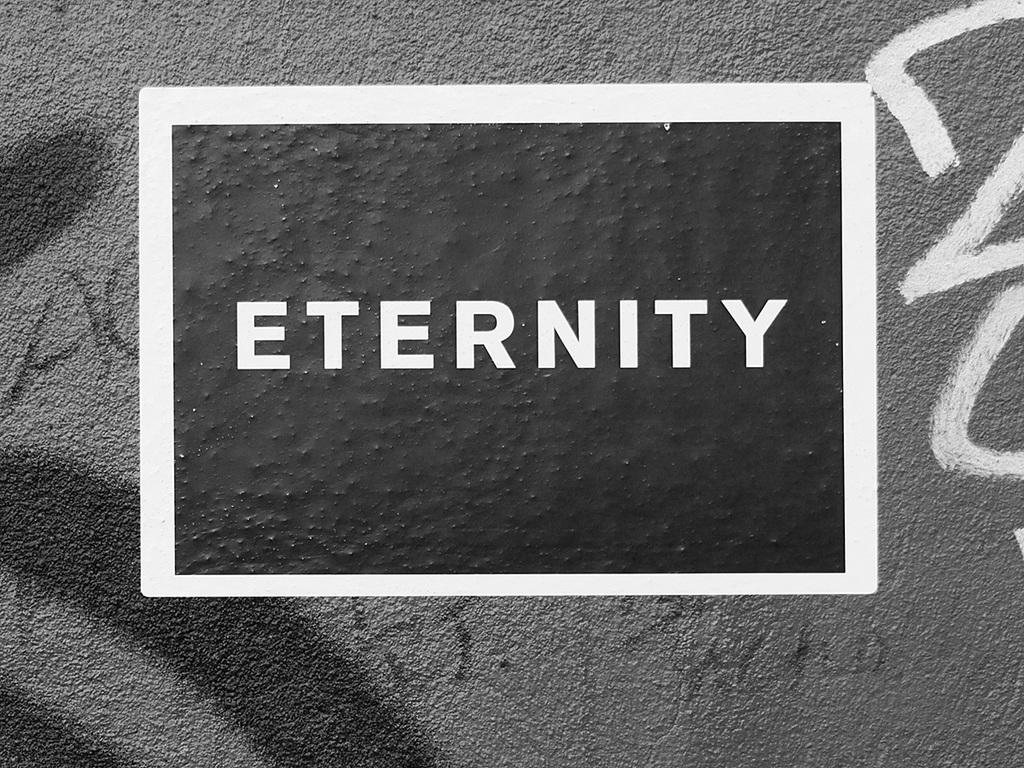<image>
Provide a brief description of the given image. A black sticker with the word Eternity in white. 